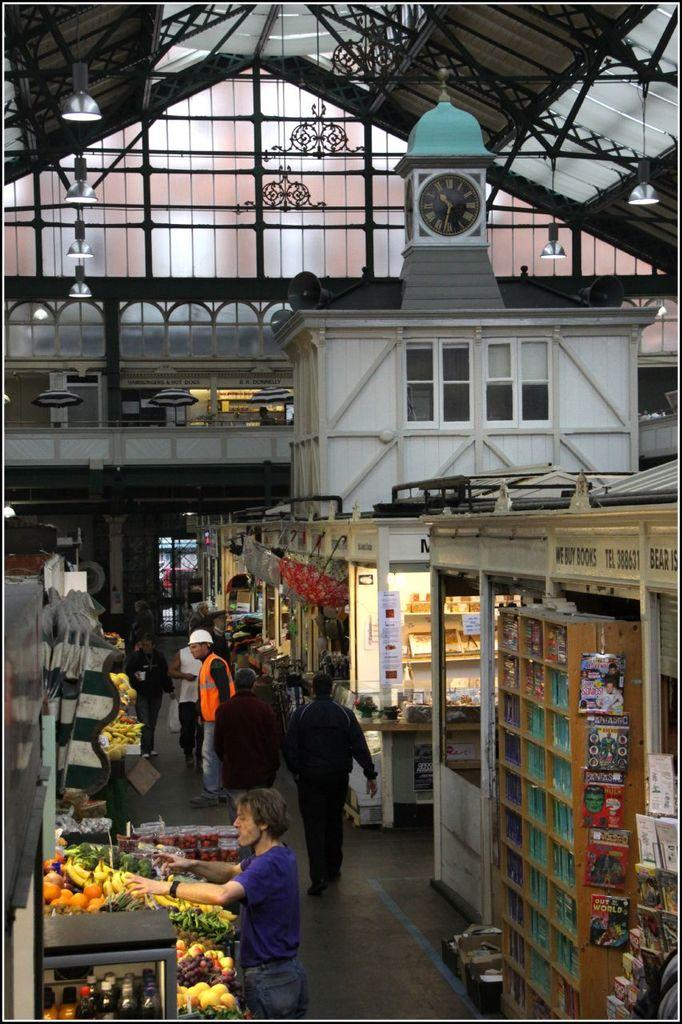What are the people in the image doing? There are many people walking in the image. Where are the people walking? The people are walking on the ground. What can be seen on either side of the ground? There are shops on either side of the ground. What is visible at the top of the image? There is a clock tower visible at the top of the image. What can be seen on the shops or buildings in the image? Window panes are present in the image. What is the chance of the pump being used in the image? There is no pump present in the image, so it's not possible to determine the chance of it being used. 